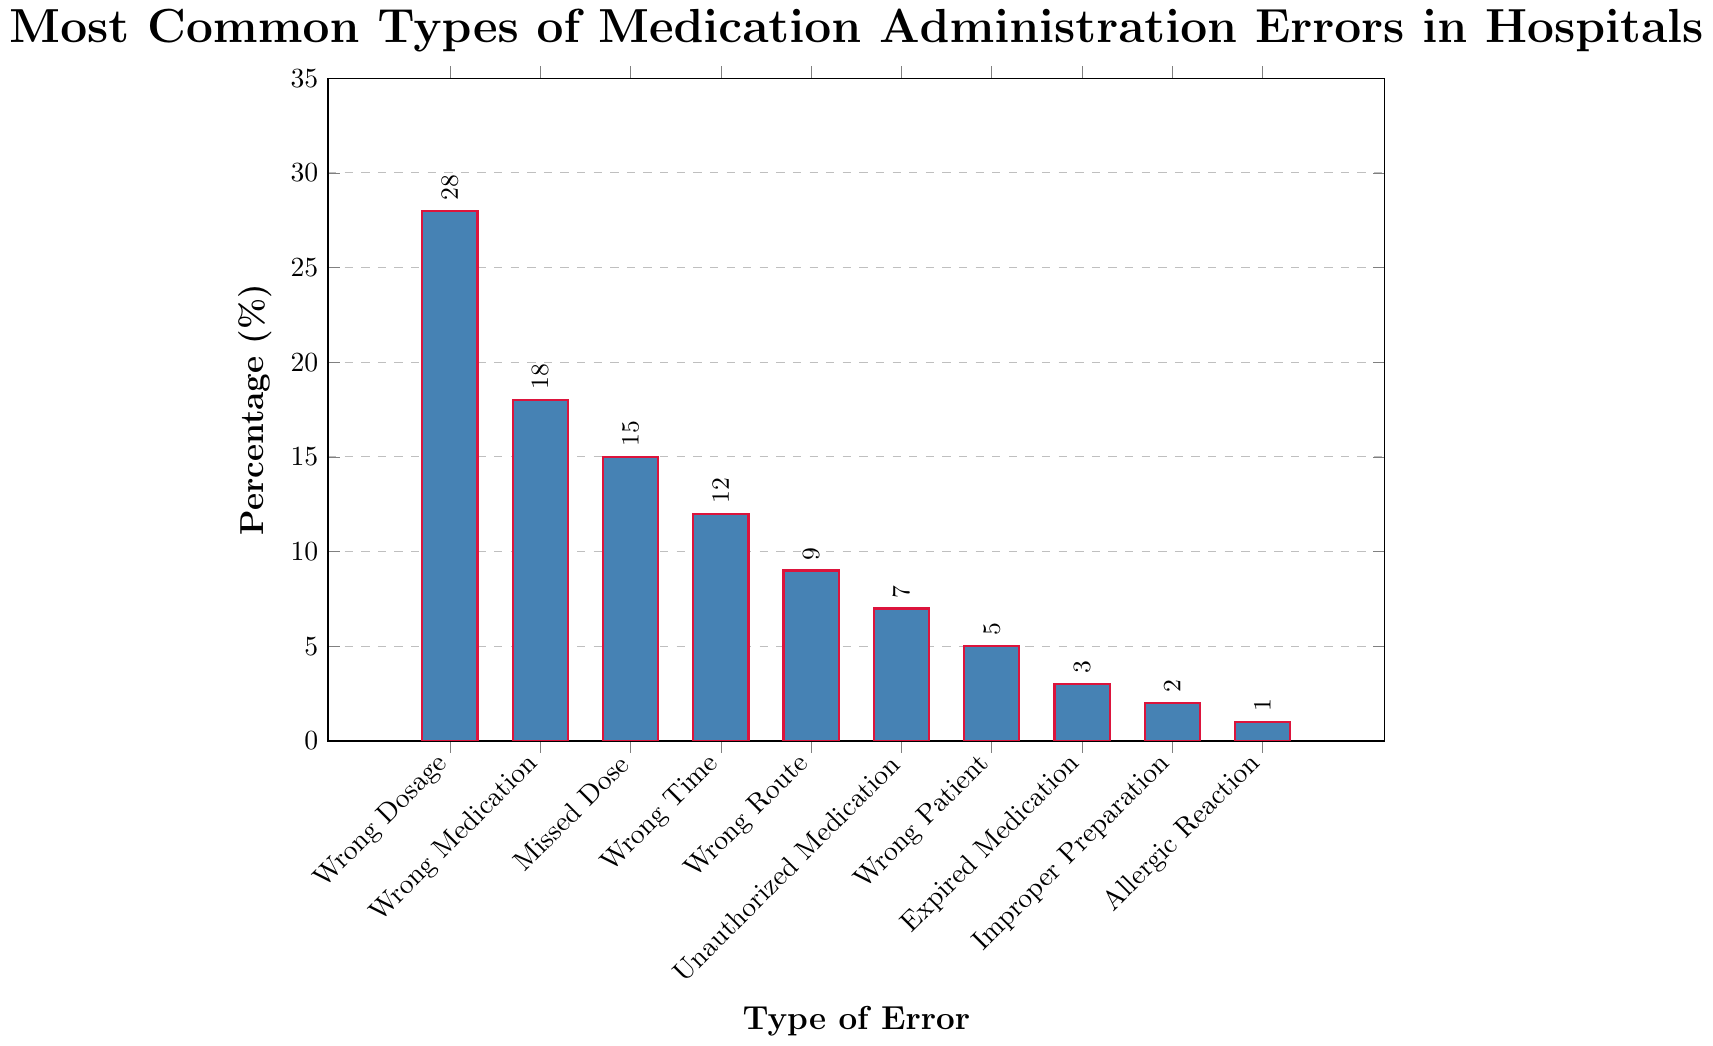what's the most common type of medication administration error? To find the most common type, we need to look for the bar with the highest percentage. From the figure, "Wrong Dosage" has the highest bar with a percentage of 28%.
Answer: Wrong Dosage which two types of errors combined make up 33% of total errors? We need to identify two types of errors whose combined percentage is 33%. "Missed Dose" has 15% and "Wrong Time" has 12%, together they make 27%. "Wrong Medication" has 18% and "Missed Dose" has 15%, together they make 33%.
Answer: Wrong Medication and Missed Dose how much more common is "Wrong Dosage" compared to "Unauthorized Medication"? We need to find the difference in percentages between "Wrong Dosage" (28%) and "Unauthorized Medication" (7%). Subtracting 7 from 28 gives us a difference of 21%.
Answer: 21% which error type has the smallest percentage? The smallest percentage is represented by the shortest bar in the chart. "Allergic Reaction" has the smallest bar with a percentage of 1%.
Answer: Allergic Reaction are there any error types that have the same percentage? We look for bars with the same height. All the percentages are unique for each type of error, so none of them have the same percentage.
Answer: No what is the combined percentage of errors related to wrong patient, wrong route, and improper preparation? We need to sum the percentages of "Wrong Patient" (5%), "Wrong Route" (9%), and "Improper Preparation" (2%). Adding these together, we get 5 + 9 + 2 = 16%.
Answer: 16% how does the percentage of "Expired Medication" compare to "Wrong Patient"? We compare their percentages directly. "Expired Medication" has 3% while "Wrong Patient" has 5%. "Expired Medication" is 2% less common than "Wrong Patient".
Answer: less common what percentage of errors involve timing (either wrong time or missed dose)? Sum the percentages of "Wrong Time" (12%) and "Missed Dose" (15%). Adding them together, we get 12 + 15 = 27%.
Answer: 27% what is the second most common type of error? The second most common type of error is represented by the second highest bar. "Wrong Medication" is the second highest with a percentage of 18%.
Answer: Wrong Medication 